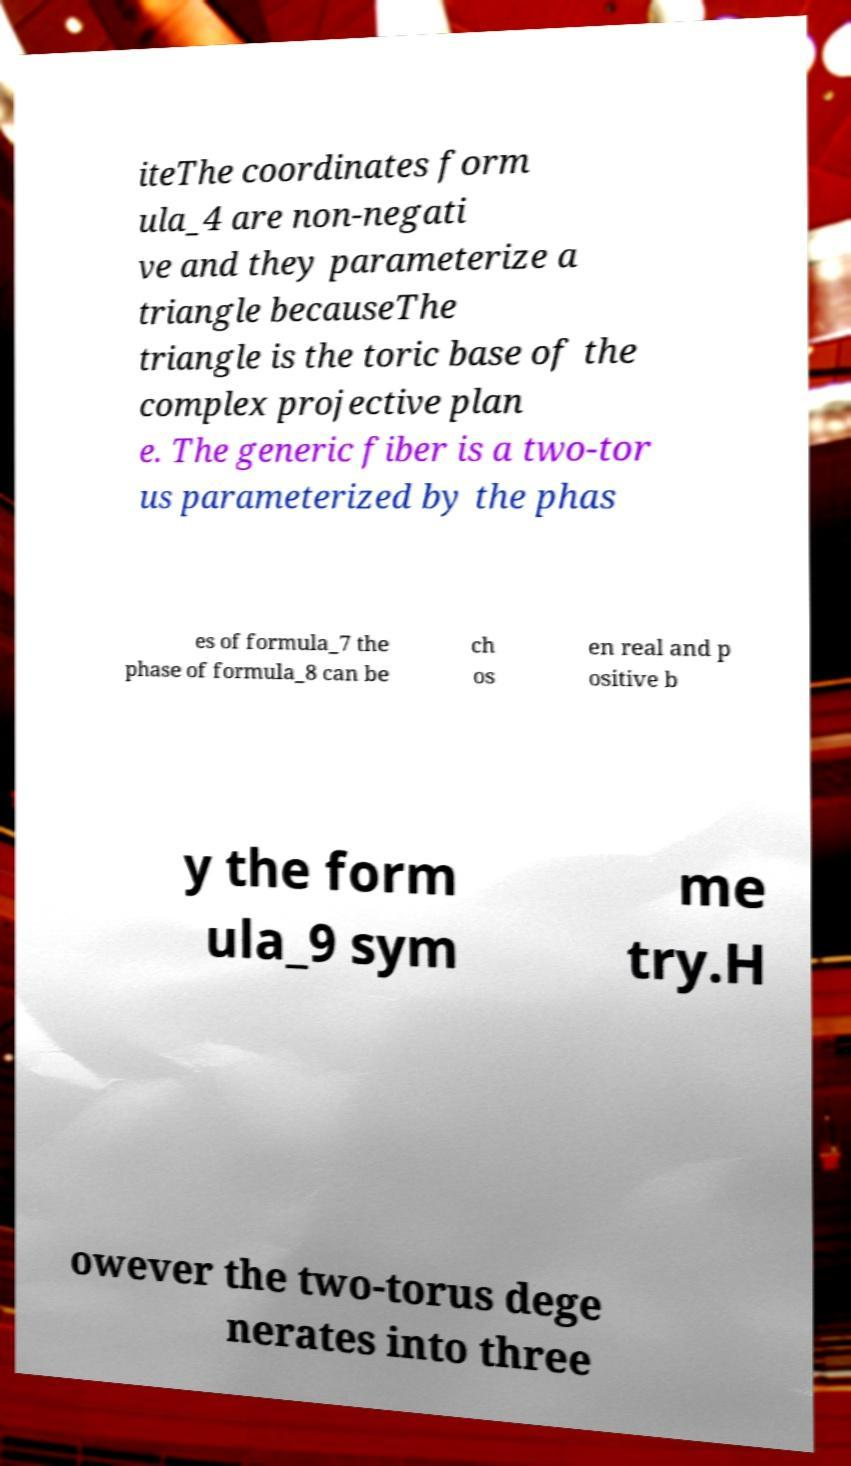Can you accurately transcribe the text from the provided image for me? iteThe coordinates form ula_4 are non-negati ve and they parameterize a triangle becauseThe triangle is the toric base of the complex projective plan e. The generic fiber is a two-tor us parameterized by the phas es of formula_7 the phase of formula_8 can be ch os en real and p ositive b y the form ula_9 sym me try.H owever the two-torus dege nerates into three 